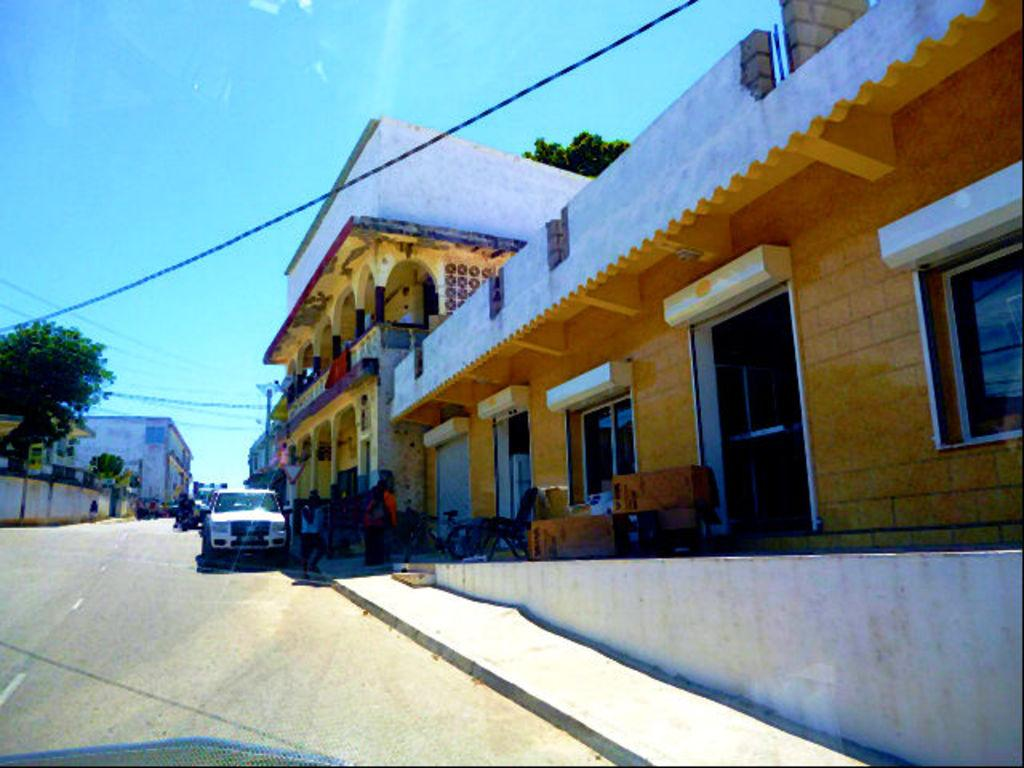How many people can be seen in the image? There are people in the image, but the exact number is not specified. What type of vehicle is on the road in the image? The image only shows a vehicle on the road, but the specific type is not mentioned. What structures are visible in the image? There are buildings in the image. What type of vegetation is present in the image? There are trees in the image. What type of furniture is in the image? There is a chair in the image. What type of infrastructure is visible in the image? There are wires in the image. What else can be seen in the image? There are objects in the image. What is visible in the background of the image? The sky is visible in the background of the image. How many pies are being served on the chair in the image? There is no mention of pies or any food items being served on the chair in the image. What type of bushes can be seen growing near the trees in the image? There is no mention of bushes in the image; only trees are mentioned. 